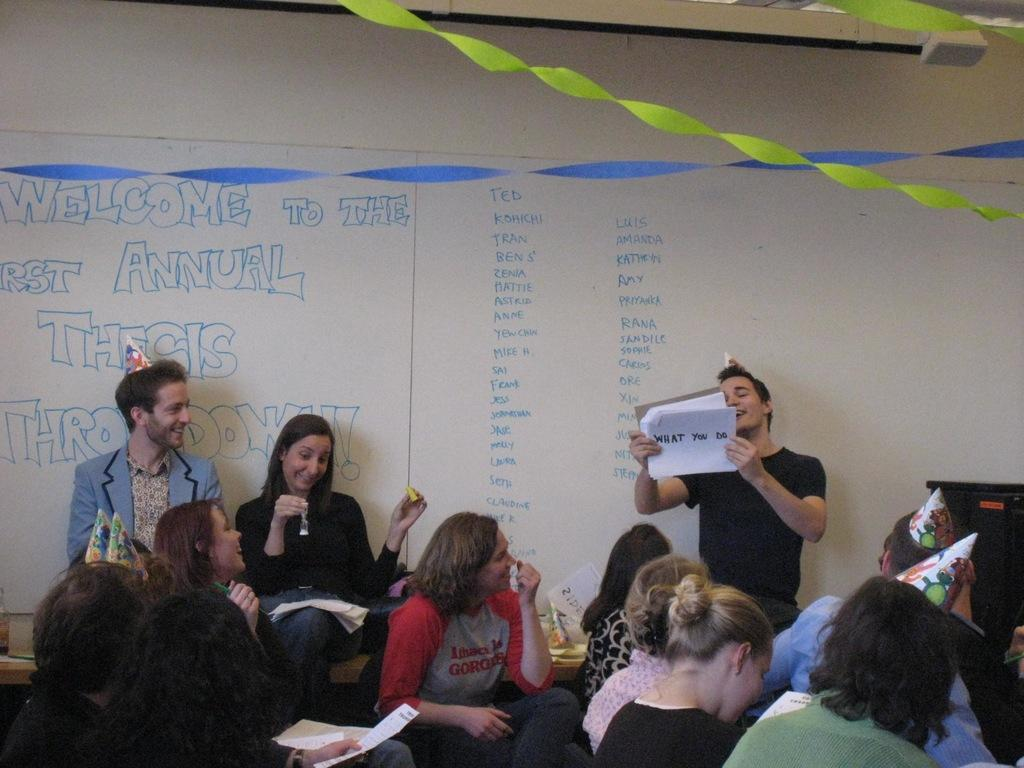What event are the people celebrating in the image? The people are celebrating their first annual thesis throwdown. How is the roof of the building decorated? The top of the roof is decorated with ribbons. What type of headwear can be seen on some people in the image? Some people present are wearing caps. What color is the eye of the person in the center of the image? There is no person with an eye visible in the image; the focus is on the celebration and the roof decoration. 